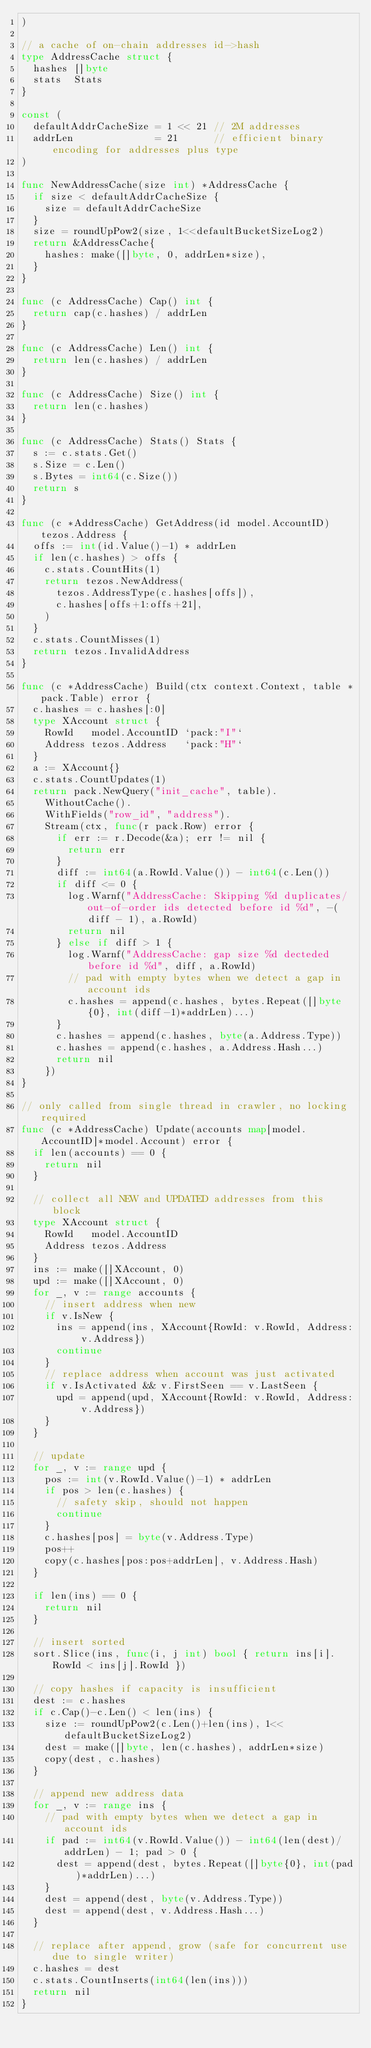<code> <loc_0><loc_0><loc_500><loc_500><_Go_>)

// a cache of on-chain addresses id->hash
type AddressCache struct {
	hashes []byte
	stats  Stats
}

const (
	defaultAddrCacheSize = 1 << 21 // 2M addresses
	addrLen              = 21      // efficient binary encoding for addresses plus type
)

func NewAddressCache(size int) *AddressCache {
	if size < defaultAddrCacheSize {
		size = defaultAddrCacheSize
	}
	size = roundUpPow2(size, 1<<defaultBucketSizeLog2)
	return &AddressCache{
		hashes: make([]byte, 0, addrLen*size),
	}
}

func (c AddressCache) Cap() int {
	return cap(c.hashes) / addrLen
}

func (c AddressCache) Len() int {
	return len(c.hashes) / addrLen
}

func (c AddressCache) Size() int {
	return len(c.hashes)
}

func (c AddressCache) Stats() Stats {
	s := c.stats.Get()
	s.Size = c.Len()
	s.Bytes = int64(c.Size())
	return s
}

func (c *AddressCache) GetAddress(id model.AccountID) tezos.Address {
	offs := int(id.Value()-1) * addrLen
	if len(c.hashes) > offs {
		c.stats.CountHits(1)
		return tezos.NewAddress(
			tezos.AddressType(c.hashes[offs]),
			c.hashes[offs+1:offs+21],
		)
	}
	c.stats.CountMisses(1)
	return tezos.InvalidAddress
}

func (c *AddressCache) Build(ctx context.Context, table *pack.Table) error {
	c.hashes = c.hashes[:0]
	type XAccount struct {
		RowId   model.AccountID `pack:"I"`
		Address tezos.Address   `pack:"H"`
	}
	a := XAccount{}
	c.stats.CountUpdates(1)
	return pack.NewQuery("init_cache", table).
		WithoutCache().
		WithFields("row_id", "address").
		Stream(ctx, func(r pack.Row) error {
			if err := r.Decode(&a); err != nil {
				return err
			}
			diff := int64(a.RowId.Value()) - int64(c.Len())
			if diff <= 0 {
				log.Warnf("AddressCache: Skipping %d duplicates/out-of-order ids detected before id %d", -(diff - 1), a.RowId)
				return nil
			} else if diff > 1 {
				log.Warnf("AddressCache: gap size %d decteded before id %d", diff, a.RowId)
				// pad with empty bytes when we detect a gap in account ids
				c.hashes = append(c.hashes, bytes.Repeat([]byte{0}, int(diff-1)*addrLen)...)
			}
			c.hashes = append(c.hashes, byte(a.Address.Type))
			c.hashes = append(c.hashes, a.Address.Hash...)
			return nil
		})
}

// only called from single thread in crawler, no locking required
func (c *AddressCache) Update(accounts map[model.AccountID]*model.Account) error {
	if len(accounts) == 0 {
		return nil
	}

	// collect all NEW and UPDATED addresses from this block
	type XAccount struct {
		RowId   model.AccountID
		Address tezos.Address
	}
	ins := make([]XAccount, 0)
	upd := make([]XAccount, 0)
	for _, v := range accounts {
		// insert address when new
		if v.IsNew {
			ins = append(ins, XAccount{RowId: v.RowId, Address: v.Address})
			continue
		}
		// replace address when account was just activated
		if v.IsActivated && v.FirstSeen == v.LastSeen {
			upd = append(upd, XAccount{RowId: v.RowId, Address: v.Address})
		}
	}

	// update
	for _, v := range upd {
		pos := int(v.RowId.Value()-1) * addrLen
		if pos > len(c.hashes) {
			// safety skip, should not happen
			continue
		}
		c.hashes[pos] = byte(v.Address.Type)
		pos++
		copy(c.hashes[pos:pos+addrLen], v.Address.Hash)
	}

	if len(ins) == 0 {
		return nil
	}

	// insert sorted
	sort.Slice(ins, func(i, j int) bool { return ins[i].RowId < ins[j].RowId })

	// copy hashes if capacity is insufficient
	dest := c.hashes
	if c.Cap()-c.Len() < len(ins) {
		size := roundUpPow2(c.Len()+len(ins), 1<<defaultBucketSizeLog2)
		dest = make([]byte, len(c.hashes), addrLen*size)
		copy(dest, c.hashes)
	}

	// append new address data
	for _, v := range ins {
		// pad with empty bytes when we detect a gap in account ids
		if pad := int64(v.RowId.Value()) - int64(len(dest)/addrLen) - 1; pad > 0 {
			dest = append(dest, bytes.Repeat([]byte{0}, int(pad)*addrLen)...)
		}
		dest = append(dest, byte(v.Address.Type))
		dest = append(dest, v.Address.Hash...)
	}

	// replace after append, grow (safe for concurrent use due to single writer)
	c.hashes = dest
	c.stats.CountInserts(int64(len(ins)))
	return nil
}
</code> 